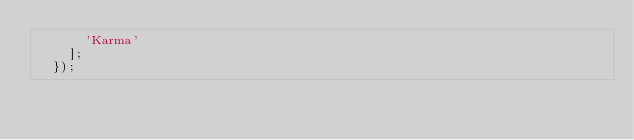Convert code to text. <code><loc_0><loc_0><loc_500><loc_500><_JavaScript_>      'Karma'
    ];
  });
</code> 